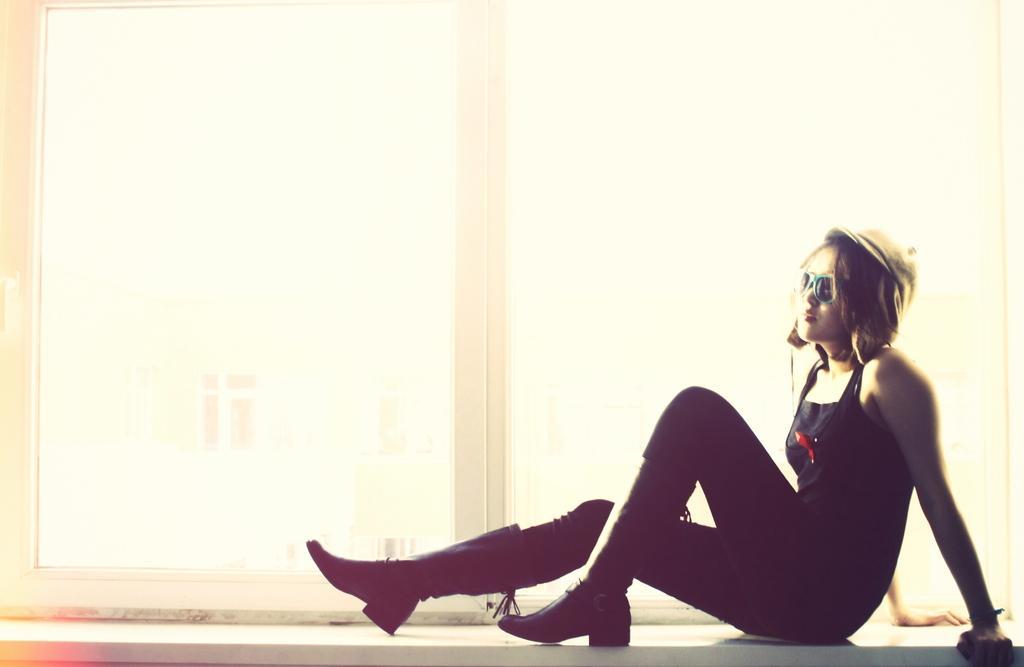In one or two sentences, can you explain what this image depicts? In this image I can see the person wearing the black color dress and sitting on the window. I can see an another building through the window. 